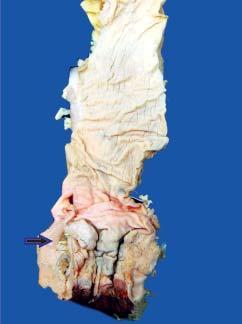what is the color of sectioned surface of rectal wall?
Answer the question using a single word or phrase. Grey-white and fleshy due to infiltration by tumour 